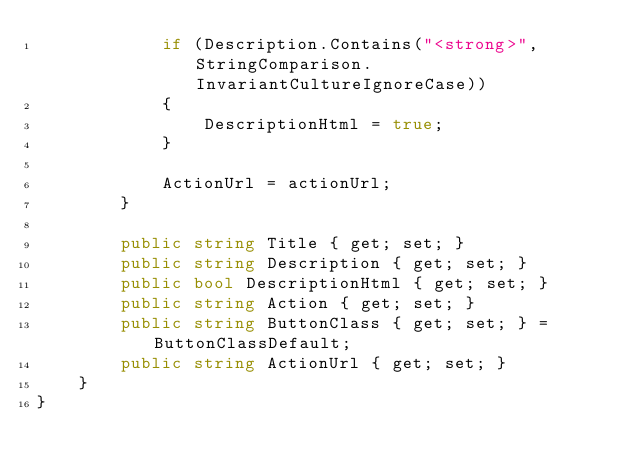<code> <loc_0><loc_0><loc_500><loc_500><_C#_>            if (Description.Contains("<strong>", StringComparison.InvariantCultureIgnoreCase))
            {
                DescriptionHtml = true;
            }

            ActionUrl = actionUrl;
        }

        public string Title { get; set; }
        public string Description { get; set; }
        public bool DescriptionHtml { get; set; }
        public string Action { get; set; }
        public string ButtonClass { get; set; } = ButtonClassDefault;
        public string ActionUrl { get; set; }
    }
}
</code> 